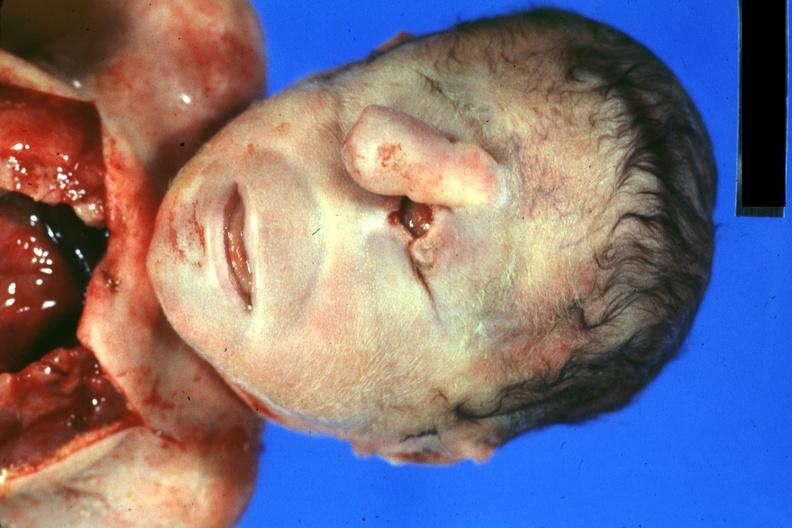what is present?
Answer the question using a single word or phrase. Cyclops 